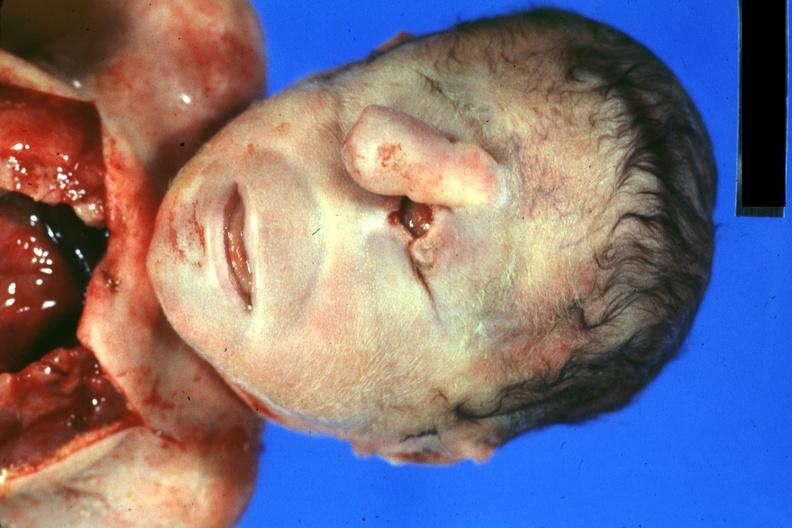what is present?
Answer the question using a single word or phrase. Cyclops 